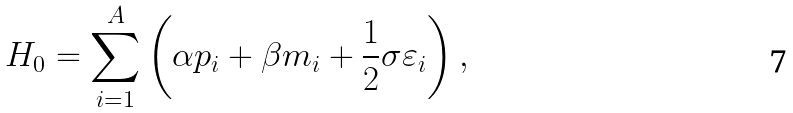<formula> <loc_0><loc_0><loc_500><loc_500>H _ { 0 } = \sum _ { i = 1 } ^ { A } \left ( \alpha { p } _ { i } + \beta m _ { i } + \frac { 1 } { 2 } \sigma \varepsilon _ { i } \right ) ,</formula> 